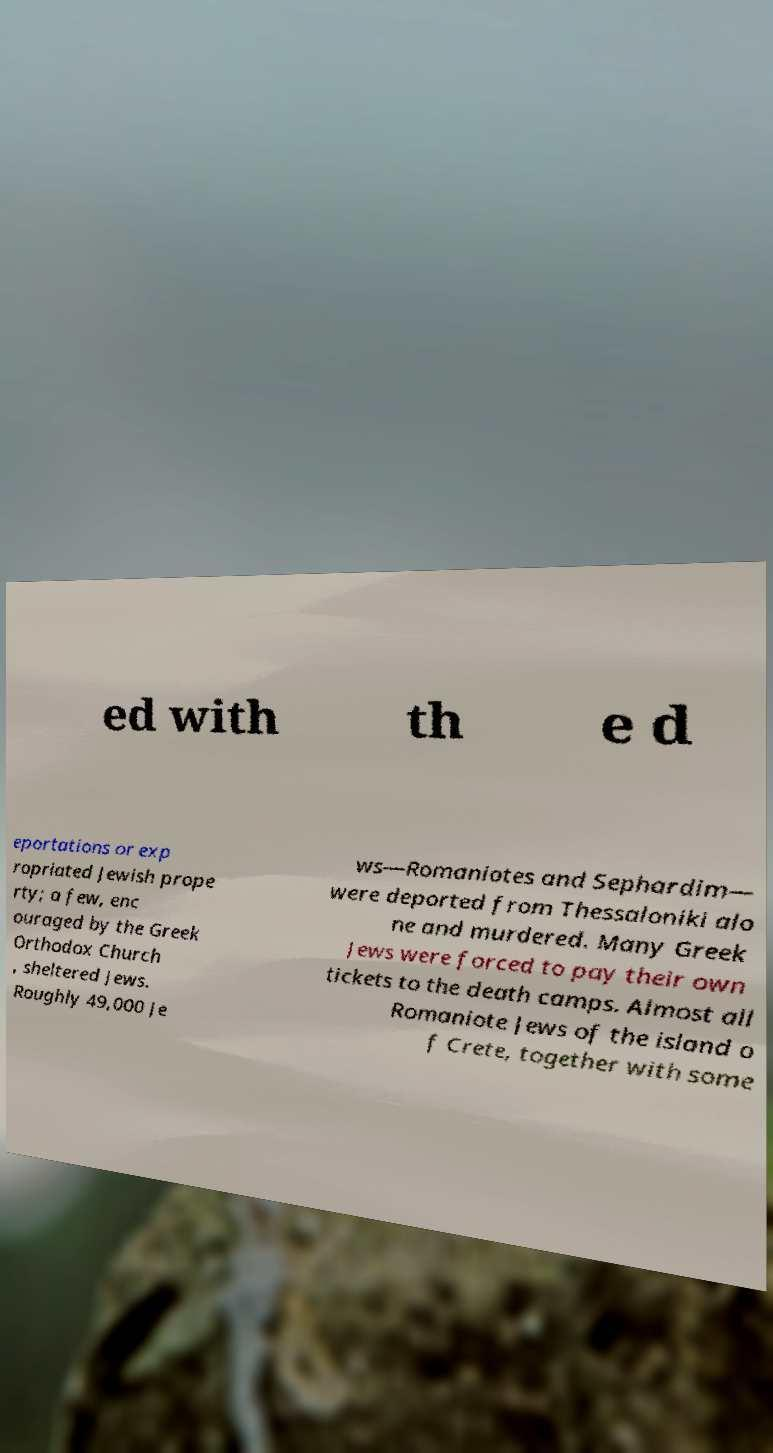Could you assist in decoding the text presented in this image and type it out clearly? ed with th e d eportations or exp ropriated Jewish prope rty; a few, enc ouraged by the Greek Orthodox Church , sheltered Jews. Roughly 49,000 Je ws—Romaniotes and Sephardim— were deported from Thessaloniki alo ne and murdered. Many Greek Jews were forced to pay their own tickets to the death camps. Almost all Romaniote Jews of the island o f Crete, together with some 